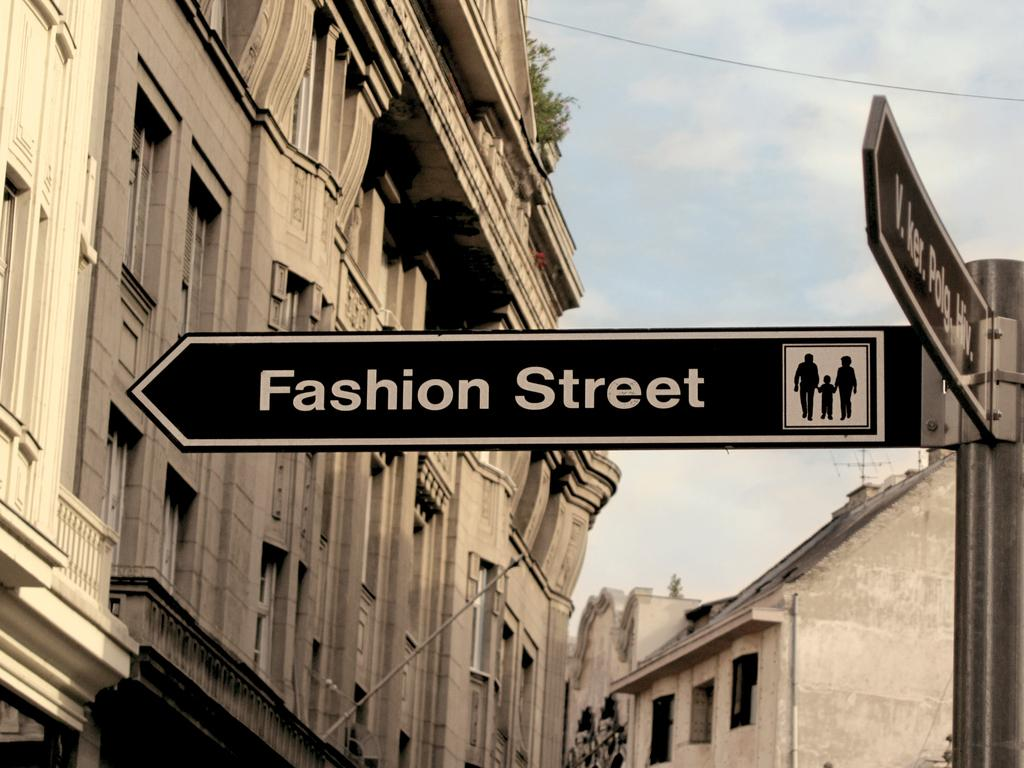What is the main object in the image? There is a sign board in the image. What can be seen behind the sign board? Buildings are visible behind the sign board. What is visible at the top right of the image? The sky is present at the top right of the image. What is the condition of the sky in the image? Clouds are visible in the sky. What type of coil is wrapped around the sign board in the image? There is no coil present in the image; it only features a sign board and buildings in the background. Can you see any ghosts interacting with the sign board in the image? There are no ghosts present in the image; it only features a sign board, buildings, and clouds in the sky. 